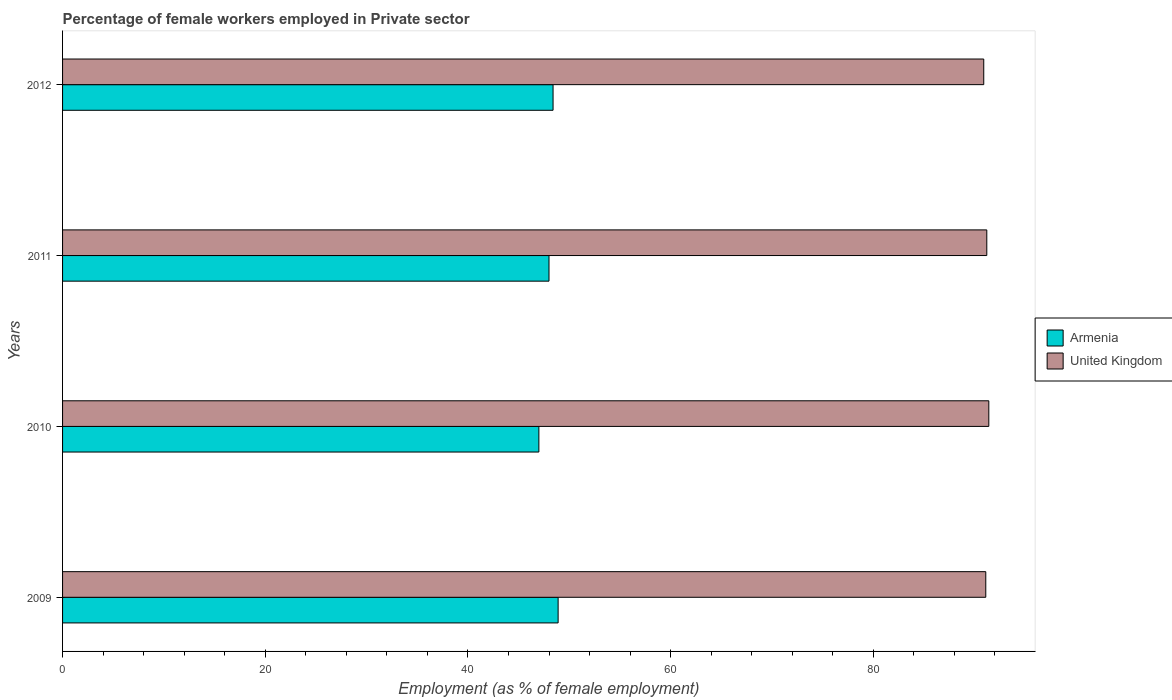How many different coloured bars are there?
Your answer should be compact. 2. Are the number of bars on each tick of the Y-axis equal?
Offer a terse response. Yes. How many bars are there on the 2nd tick from the top?
Provide a short and direct response. 2. What is the percentage of females employed in Private sector in Armenia in 2009?
Your response must be concise. 48.9. Across all years, what is the maximum percentage of females employed in Private sector in Armenia?
Ensure brevity in your answer.  48.9. Across all years, what is the minimum percentage of females employed in Private sector in Armenia?
Provide a short and direct response. 47. In which year was the percentage of females employed in Private sector in Armenia maximum?
Ensure brevity in your answer.  2009. What is the total percentage of females employed in Private sector in Armenia in the graph?
Keep it short and to the point. 192.3. What is the difference between the percentage of females employed in Private sector in Armenia in 2010 and the percentage of females employed in Private sector in United Kingdom in 2009?
Provide a succinct answer. -44.1. What is the average percentage of females employed in Private sector in United Kingdom per year?
Offer a very short reply. 91.15. In the year 2010, what is the difference between the percentage of females employed in Private sector in Armenia and percentage of females employed in Private sector in United Kingdom?
Make the answer very short. -44.4. What is the ratio of the percentage of females employed in Private sector in United Kingdom in 2010 to that in 2012?
Ensure brevity in your answer.  1.01. What is the difference between the highest and the second highest percentage of females employed in Private sector in United Kingdom?
Offer a terse response. 0.2. What is the difference between the highest and the lowest percentage of females employed in Private sector in Armenia?
Your response must be concise. 1.9. In how many years, is the percentage of females employed in Private sector in Armenia greater than the average percentage of females employed in Private sector in Armenia taken over all years?
Your answer should be compact. 2. What does the 2nd bar from the top in 2010 represents?
Make the answer very short. Armenia. What does the 1st bar from the bottom in 2009 represents?
Your answer should be very brief. Armenia. How many bars are there?
Give a very brief answer. 8. Are all the bars in the graph horizontal?
Give a very brief answer. Yes. Does the graph contain grids?
Offer a terse response. No. How are the legend labels stacked?
Provide a succinct answer. Vertical. What is the title of the graph?
Keep it short and to the point. Percentage of female workers employed in Private sector. Does "Madagascar" appear as one of the legend labels in the graph?
Make the answer very short. No. What is the label or title of the X-axis?
Provide a succinct answer. Employment (as % of female employment). What is the label or title of the Y-axis?
Keep it short and to the point. Years. What is the Employment (as % of female employment) of Armenia in 2009?
Ensure brevity in your answer.  48.9. What is the Employment (as % of female employment) in United Kingdom in 2009?
Provide a succinct answer. 91.1. What is the Employment (as % of female employment) in United Kingdom in 2010?
Offer a terse response. 91.4. What is the Employment (as % of female employment) of United Kingdom in 2011?
Your answer should be compact. 91.2. What is the Employment (as % of female employment) in Armenia in 2012?
Your answer should be very brief. 48.4. What is the Employment (as % of female employment) of United Kingdom in 2012?
Your response must be concise. 90.9. Across all years, what is the maximum Employment (as % of female employment) in Armenia?
Provide a succinct answer. 48.9. Across all years, what is the maximum Employment (as % of female employment) in United Kingdom?
Provide a short and direct response. 91.4. Across all years, what is the minimum Employment (as % of female employment) in United Kingdom?
Your answer should be very brief. 90.9. What is the total Employment (as % of female employment) of Armenia in the graph?
Offer a terse response. 192.3. What is the total Employment (as % of female employment) of United Kingdom in the graph?
Give a very brief answer. 364.6. What is the difference between the Employment (as % of female employment) of Armenia in 2009 and that in 2010?
Your response must be concise. 1.9. What is the difference between the Employment (as % of female employment) of United Kingdom in 2009 and that in 2010?
Provide a short and direct response. -0.3. What is the difference between the Employment (as % of female employment) in Armenia in 2009 and that in 2011?
Provide a short and direct response. 0.9. What is the difference between the Employment (as % of female employment) in United Kingdom in 2009 and that in 2011?
Your answer should be compact. -0.1. What is the difference between the Employment (as % of female employment) of Armenia in 2009 and that in 2012?
Keep it short and to the point. 0.5. What is the difference between the Employment (as % of female employment) of Armenia in 2010 and that in 2011?
Offer a terse response. -1. What is the difference between the Employment (as % of female employment) in United Kingdom in 2010 and that in 2012?
Offer a terse response. 0.5. What is the difference between the Employment (as % of female employment) in United Kingdom in 2011 and that in 2012?
Provide a short and direct response. 0.3. What is the difference between the Employment (as % of female employment) in Armenia in 2009 and the Employment (as % of female employment) in United Kingdom in 2010?
Provide a succinct answer. -42.5. What is the difference between the Employment (as % of female employment) in Armenia in 2009 and the Employment (as % of female employment) in United Kingdom in 2011?
Your answer should be very brief. -42.3. What is the difference between the Employment (as % of female employment) in Armenia in 2009 and the Employment (as % of female employment) in United Kingdom in 2012?
Ensure brevity in your answer.  -42. What is the difference between the Employment (as % of female employment) in Armenia in 2010 and the Employment (as % of female employment) in United Kingdom in 2011?
Your answer should be very brief. -44.2. What is the difference between the Employment (as % of female employment) of Armenia in 2010 and the Employment (as % of female employment) of United Kingdom in 2012?
Your answer should be compact. -43.9. What is the difference between the Employment (as % of female employment) of Armenia in 2011 and the Employment (as % of female employment) of United Kingdom in 2012?
Offer a very short reply. -42.9. What is the average Employment (as % of female employment) in Armenia per year?
Offer a very short reply. 48.08. What is the average Employment (as % of female employment) in United Kingdom per year?
Your response must be concise. 91.15. In the year 2009, what is the difference between the Employment (as % of female employment) in Armenia and Employment (as % of female employment) in United Kingdom?
Your answer should be compact. -42.2. In the year 2010, what is the difference between the Employment (as % of female employment) of Armenia and Employment (as % of female employment) of United Kingdom?
Offer a very short reply. -44.4. In the year 2011, what is the difference between the Employment (as % of female employment) of Armenia and Employment (as % of female employment) of United Kingdom?
Make the answer very short. -43.2. In the year 2012, what is the difference between the Employment (as % of female employment) in Armenia and Employment (as % of female employment) in United Kingdom?
Offer a terse response. -42.5. What is the ratio of the Employment (as % of female employment) in Armenia in 2009 to that in 2010?
Give a very brief answer. 1.04. What is the ratio of the Employment (as % of female employment) in United Kingdom in 2009 to that in 2010?
Offer a very short reply. 1. What is the ratio of the Employment (as % of female employment) of Armenia in 2009 to that in 2011?
Offer a very short reply. 1.02. What is the ratio of the Employment (as % of female employment) in United Kingdom in 2009 to that in 2011?
Offer a terse response. 1. What is the ratio of the Employment (as % of female employment) of Armenia in 2009 to that in 2012?
Give a very brief answer. 1.01. What is the ratio of the Employment (as % of female employment) of Armenia in 2010 to that in 2011?
Your response must be concise. 0.98. What is the ratio of the Employment (as % of female employment) of United Kingdom in 2010 to that in 2011?
Ensure brevity in your answer.  1. What is the ratio of the Employment (as % of female employment) of Armenia in 2010 to that in 2012?
Provide a short and direct response. 0.97. What is the ratio of the Employment (as % of female employment) of United Kingdom in 2010 to that in 2012?
Your answer should be compact. 1.01. What is the ratio of the Employment (as % of female employment) in Armenia in 2011 to that in 2012?
Give a very brief answer. 0.99. 